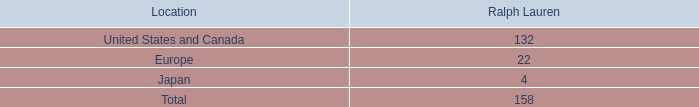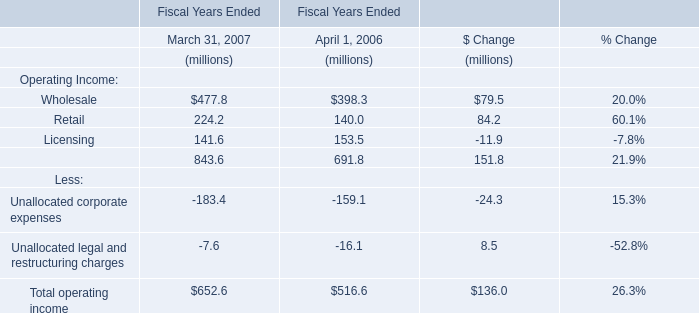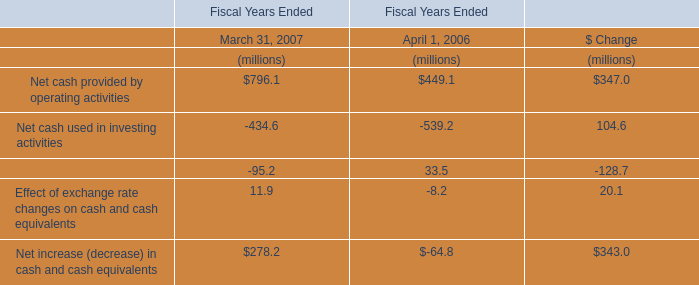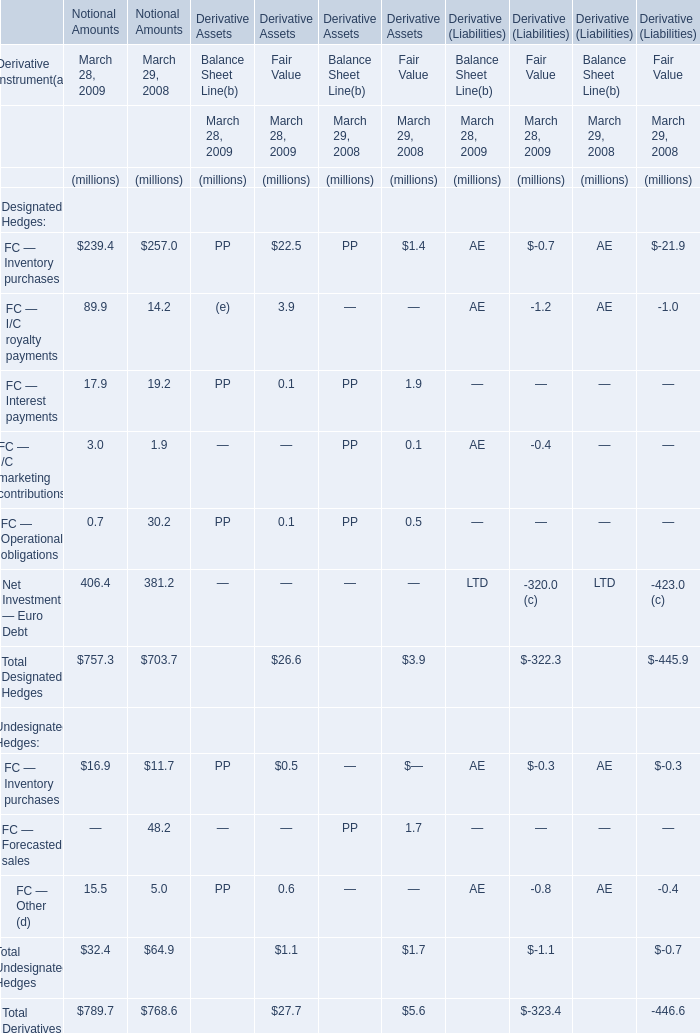What was the total amount of elements for Notional Amounts in the range of 200 and 500 in 2009 ? (in million) 
Computations: (239.4 + 406.4)
Answer: 645.8. 